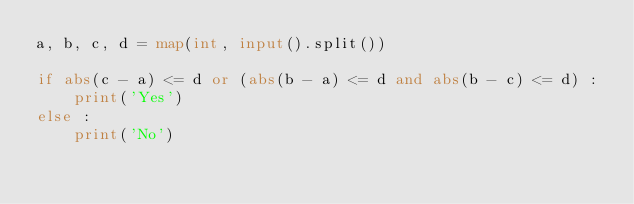<code> <loc_0><loc_0><loc_500><loc_500><_Python_>a, b, c, d = map(int, input().split())

if abs(c - a) <= d or (abs(b - a) <= d and abs(b - c) <= d) :
    print('Yes')
else :
    print('No')</code> 